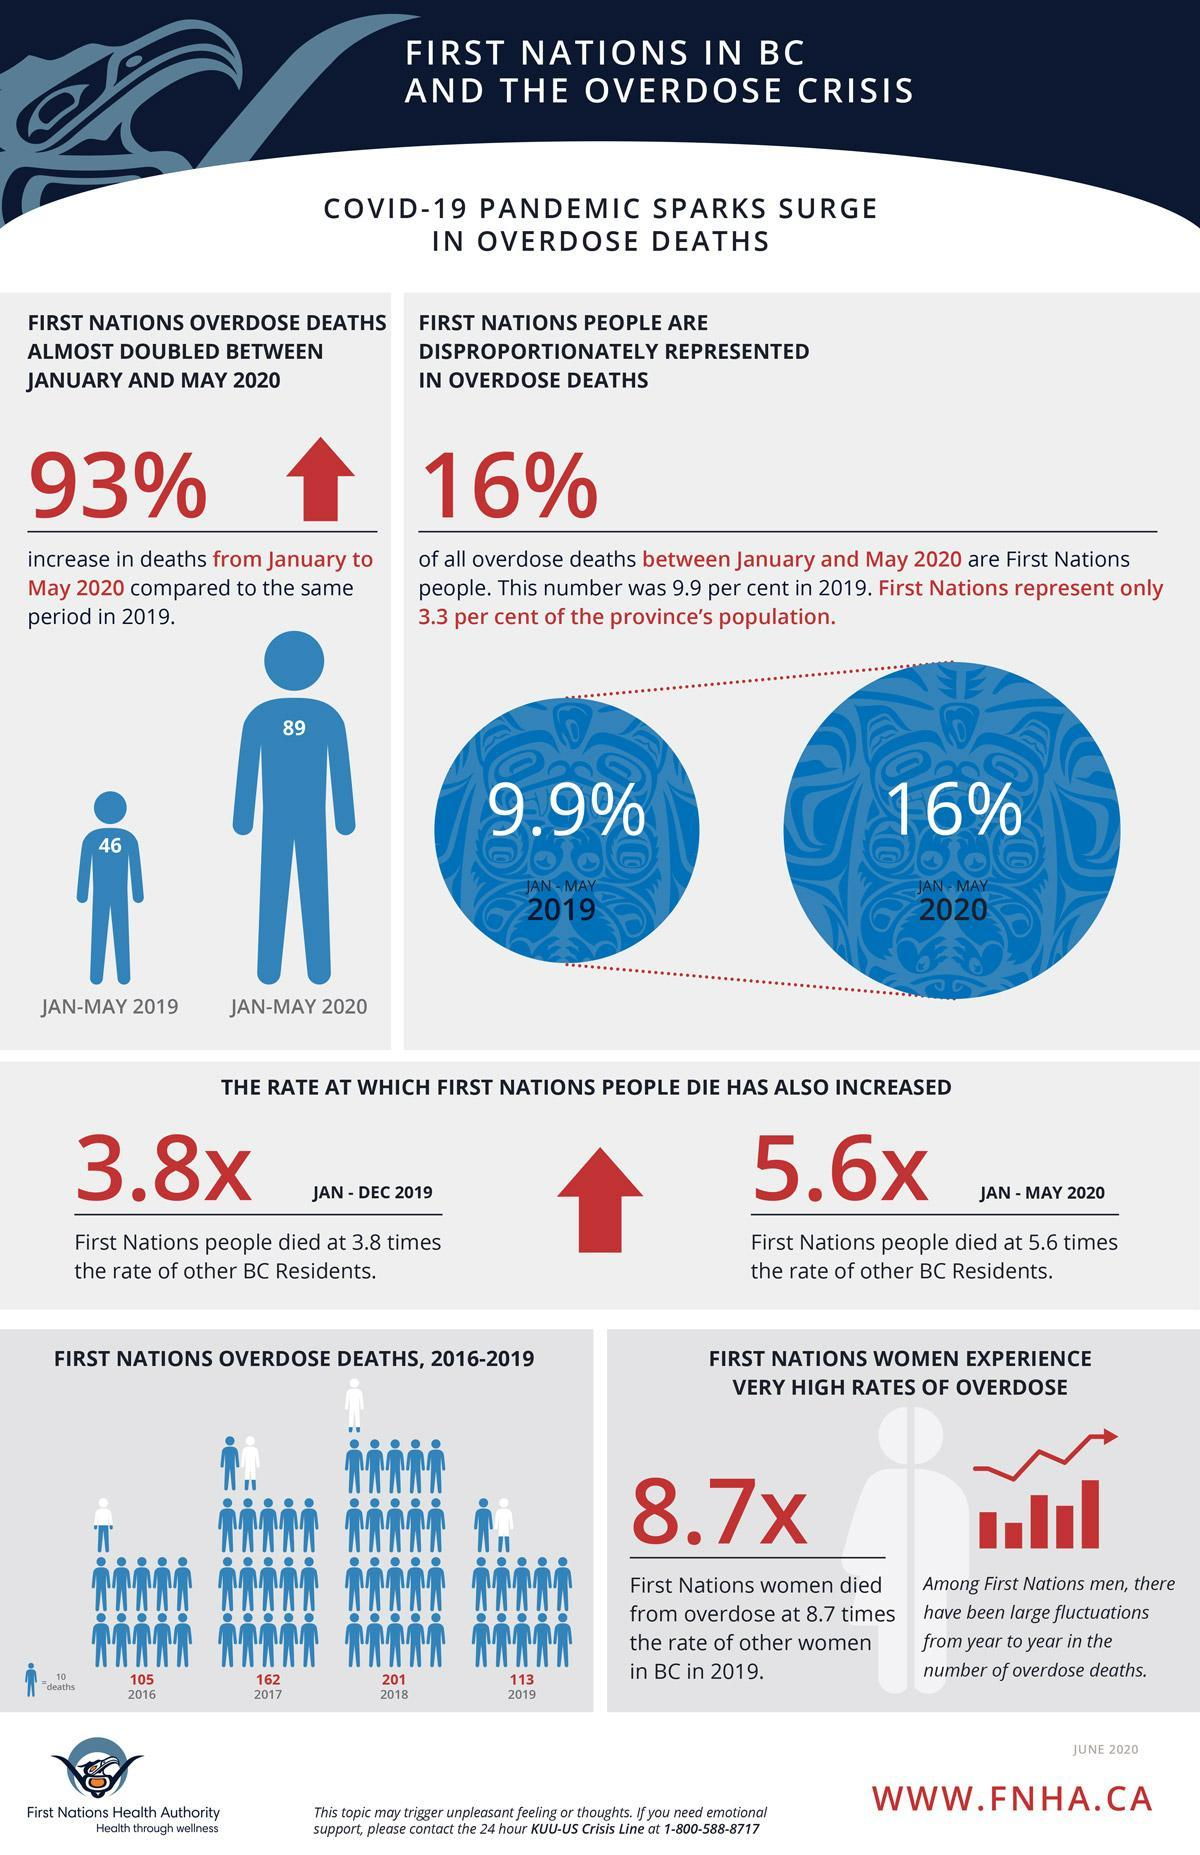How much is the increase in percentage of deaths due to overdose from 2019 to 2020?
Answer the question with a short phrase. 6.1 What is the death rate of First Nations people in the present year? 5.6x What is the difference between the death rate of people in 2019 and 2020? 1.8 In which year deaths due to overdose was at its peak? 2018 How many First Nation deaths due to overdose happened in the year 2017? 162 How many Overdose deaths happened in the year 2020? 16% How many First nations death happened in 2020? 89 In which year second highest no of overdose deaths happened? 2017 How much is the difference between the no of deaths in 2019 to 2020? 43 What is the no of deaths of First Nations in 2019? 46 